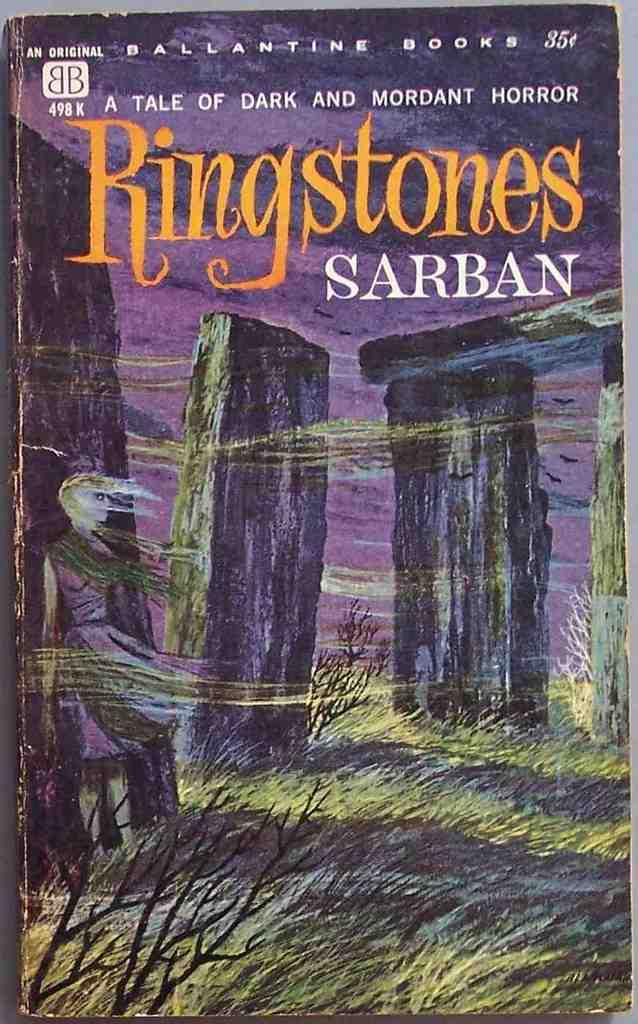<image>
Summarize the visual content of the image. The cover for Ringstones by Sarban that shows a girl among large rocks. 